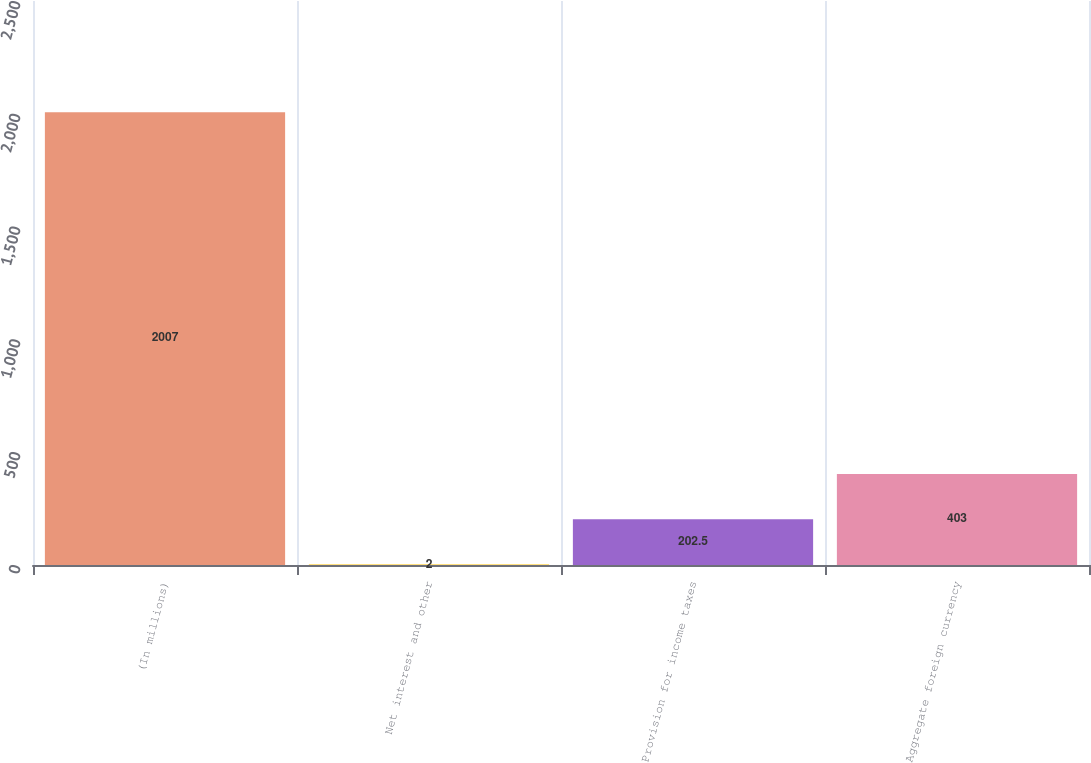Convert chart. <chart><loc_0><loc_0><loc_500><loc_500><bar_chart><fcel>(In millions)<fcel>Net interest and other<fcel>Provision for income taxes<fcel>Aggregate foreign currency<nl><fcel>2007<fcel>2<fcel>202.5<fcel>403<nl></chart> 